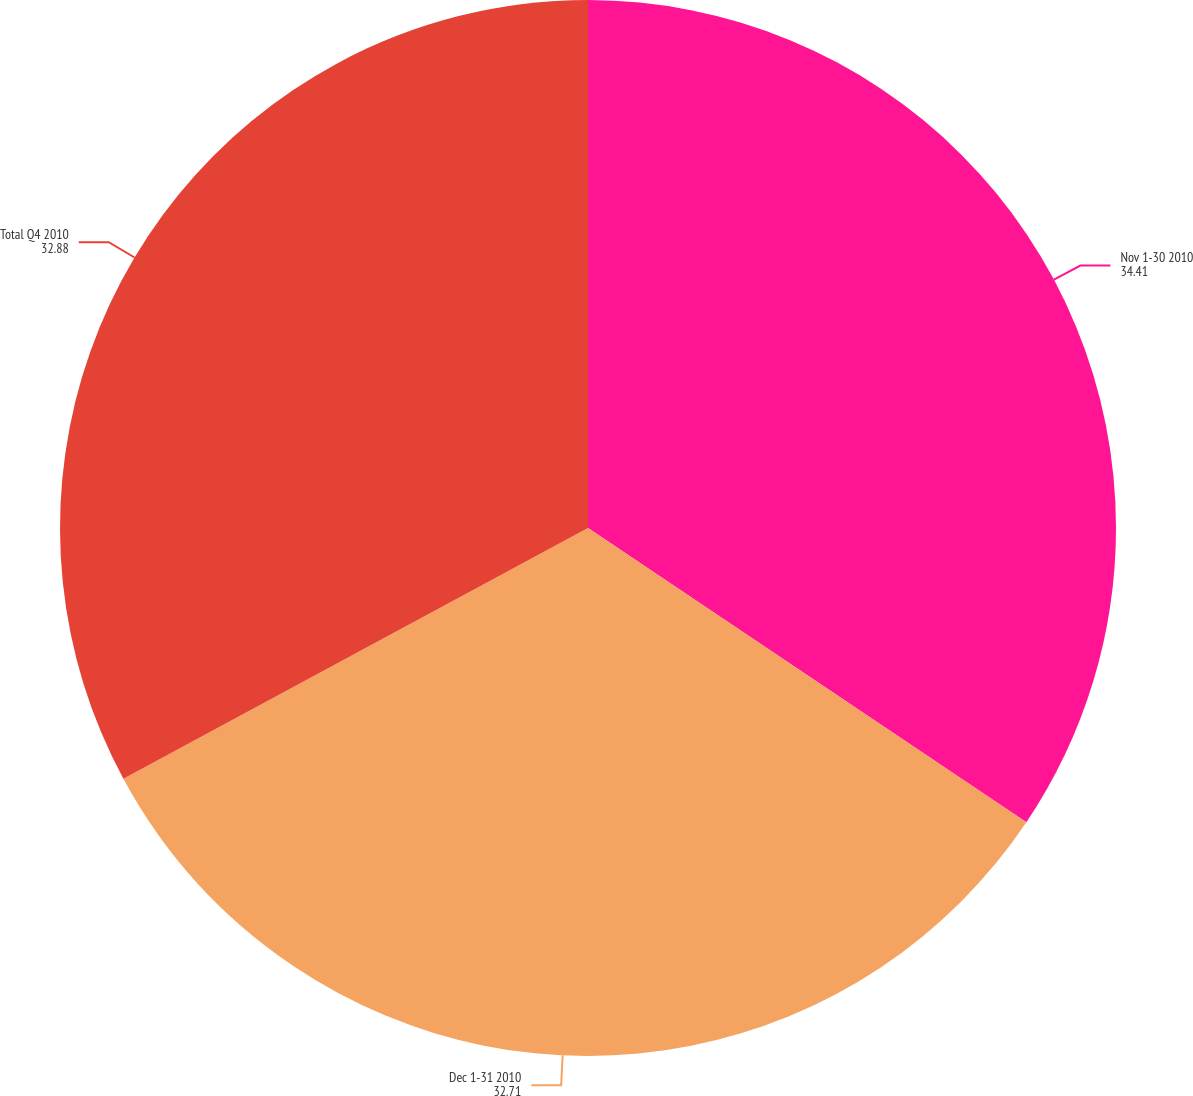<chart> <loc_0><loc_0><loc_500><loc_500><pie_chart><fcel>Nov 1-30 2010<fcel>Dec 1-31 2010<fcel>Total Q4 2010<nl><fcel>34.41%<fcel>32.71%<fcel>32.88%<nl></chart> 